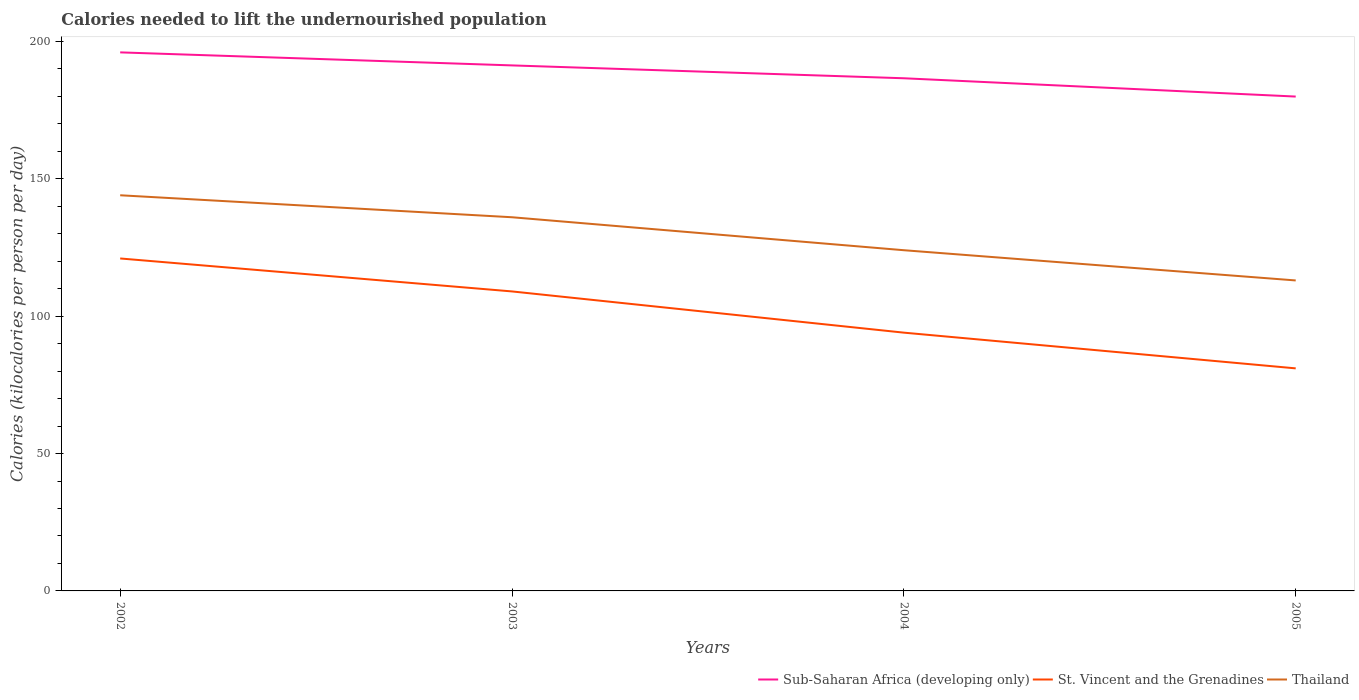How many different coloured lines are there?
Your answer should be very brief. 3. Does the line corresponding to Sub-Saharan Africa (developing only) intersect with the line corresponding to St. Vincent and the Grenadines?
Keep it short and to the point. No. Is the number of lines equal to the number of legend labels?
Provide a succinct answer. Yes. Across all years, what is the maximum total calories needed to lift the undernourished population in Sub-Saharan Africa (developing only)?
Make the answer very short. 179.92. In which year was the total calories needed to lift the undernourished population in Thailand maximum?
Ensure brevity in your answer.  2005. What is the total total calories needed to lift the undernourished population in Thailand in the graph?
Provide a short and direct response. 12. What is the difference between the highest and the second highest total calories needed to lift the undernourished population in St. Vincent and the Grenadines?
Keep it short and to the point. 40. How many years are there in the graph?
Keep it short and to the point. 4. Does the graph contain any zero values?
Give a very brief answer. No. How are the legend labels stacked?
Ensure brevity in your answer.  Horizontal. What is the title of the graph?
Make the answer very short. Calories needed to lift the undernourished population. What is the label or title of the Y-axis?
Your answer should be compact. Calories (kilocalories per person per day). What is the Calories (kilocalories per person per day) in Sub-Saharan Africa (developing only) in 2002?
Give a very brief answer. 196.01. What is the Calories (kilocalories per person per day) in St. Vincent and the Grenadines in 2002?
Your answer should be very brief. 121. What is the Calories (kilocalories per person per day) of Thailand in 2002?
Your answer should be compact. 144. What is the Calories (kilocalories per person per day) in Sub-Saharan Africa (developing only) in 2003?
Your answer should be very brief. 191.26. What is the Calories (kilocalories per person per day) of St. Vincent and the Grenadines in 2003?
Keep it short and to the point. 109. What is the Calories (kilocalories per person per day) in Thailand in 2003?
Offer a terse response. 136. What is the Calories (kilocalories per person per day) of Sub-Saharan Africa (developing only) in 2004?
Offer a very short reply. 186.58. What is the Calories (kilocalories per person per day) of St. Vincent and the Grenadines in 2004?
Ensure brevity in your answer.  94. What is the Calories (kilocalories per person per day) of Thailand in 2004?
Offer a terse response. 124. What is the Calories (kilocalories per person per day) in Sub-Saharan Africa (developing only) in 2005?
Your response must be concise. 179.92. What is the Calories (kilocalories per person per day) of St. Vincent and the Grenadines in 2005?
Provide a short and direct response. 81. What is the Calories (kilocalories per person per day) in Thailand in 2005?
Keep it short and to the point. 113. Across all years, what is the maximum Calories (kilocalories per person per day) in Sub-Saharan Africa (developing only)?
Provide a succinct answer. 196.01. Across all years, what is the maximum Calories (kilocalories per person per day) in St. Vincent and the Grenadines?
Keep it short and to the point. 121. Across all years, what is the maximum Calories (kilocalories per person per day) in Thailand?
Give a very brief answer. 144. Across all years, what is the minimum Calories (kilocalories per person per day) in Sub-Saharan Africa (developing only)?
Provide a short and direct response. 179.92. Across all years, what is the minimum Calories (kilocalories per person per day) of Thailand?
Your answer should be very brief. 113. What is the total Calories (kilocalories per person per day) of Sub-Saharan Africa (developing only) in the graph?
Keep it short and to the point. 753.78. What is the total Calories (kilocalories per person per day) of St. Vincent and the Grenadines in the graph?
Provide a succinct answer. 405. What is the total Calories (kilocalories per person per day) of Thailand in the graph?
Ensure brevity in your answer.  517. What is the difference between the Calories (kilocalories per person per day) of Sub-Saharan Africa (developing only) in 2002 and that in 2003?
Your answer should be compact. 4.74. What is the difference between the Calories (kilocalories per person per day) in St. Vincent and the Grenadines in 2002 and that in 2003?
Offer a terse response. 12. What is the difference between the Calories (kilocalories per person per day) in Sub-Saharan Africa (developing only) in 2002 and that in 2004?
Offer a very short reply. 9.42. What is the difference between the Calories (kilocalories per person per day) of Sub-Saharan Africa (developing only) in 2002 and that in 2005?
Provide a short and direct response. 16.08. What is the difference between the Calories (kilocalories per person per day) of St. Vincent and the Grenadines in 2002 and that in 2005?
Provide a succinct answer. 40. What is the difference between the Calories (kilocalories per person per day) of Sub-Saharan Africa (developing only) in 2003 and that in 2004?
Make the answer very short. 4.68. What is the difference between the Calories (kilocalories per person per day) of St. Vincent and the Grenadines in 2003 and that in 2004?
Keep it short and to the point. 15. What is the difference between the Calories (kilocalories per person per day) of Thailand in 2003 and that in 2004?
Give a very brief answer. 12. What is the difference between the Calories (kilocalories per person per day) in Sub-Saharan Africa (developing only) in 2003 and that in 2005?
Your response must be concise. 11.34. What is the difference between the Calories (kilocalories per person per day) of St. Vincent and the Grenadines in 2003 and that in 2005?
Offer a very short reply. 28. What is the difference between the Calories (kilocalories per person per day) of Sub-Saharan Africa (developing only) in 2004 and that in 2005?
Your answer should be compact. 6.66. What is the difference between the Calories (kilocalories per person per day) of Thailand in 2004 and that in 2005?
Your answer should be compact. 11. What is the difference between the Calories (kilocalories per person per day) of Sub-Saharan Africa (developing only) in 2002 and the Calories (kilocalories per person per day) of St. Vincent and the Grenadines in 2003?
Provide a succinct answer. 87.01. What is the difference between the Calories (kilocalories per person per day) of Sub-Saharan Africa (developing only) in 2002 and the Calories (kilocalories per person per day) of Thailand in 2003?
Keep it short and to the point. 60.01. What is the difference between the Calories (kilocalories per person per day) of St. Vincent and the Grenadines in 2002 and the Calories (kilocalories per person per day) of Thailand in 2003?
Offer a terse response. -15. What is the difference between the Calories (kilocalories per person per day) of Sub-Saharan Africa (developing only) in 2002 and the Calories (kilocalories per person per day) of St. Vincent and the Grenadines in 2004?
Your answer should be very brief. 102.01. What is the difference between the Calories (kilocalories per person per day) in Sub-Saharan Africa (developing only) in 2002 and the Calories (kilocalories per person per day) in Thailand in 2004?
Offer a very short reply. 72.01. What is the difference between the Calories (kilocalories per person per day) in St. Vincent and the Grenadines in 2002 and the Calories (kilocalories per person per day) in Thailand in 2004?
Provide a succinct answer. -3. What is the difference between the Calories (kilocalories per person per day) of Sub-Saharan Africa (developing only) in 2002 and the Calories (kilocalories per person per day) of St. Vincent and the Grenadines in 2005?
Make the answer very short. 115.01. What is the difference between the Calories (kilocalories per person per day) of Sub-Saharan Africa (developing only) in 2002 and the Calories (kilocalories per person per day) of Thailand in 2005?
Your answer should be very brief. 83.01. What is the difference between the Calories (kilocalories per person per day) in St. Vincent and the Grenadines in 2002 and the Calories (kilocalories per person per day) in Thailand in 2005?
Make the answer very short. 8. What is the difference between the Calories (kilocalories per person per day) in Sub-Saharan Africa (developing only) in 2003 and the Calories (kilocalories per person per day) in St. Vincent and the Grenadines in 2004?
Give a very brief answer. 97.26. What is the difference between the Calories (kilocalories per person per day) in Sub-Saharan Africa (developing only) in 2003 and the Calories (kilocalories per person per day) in Thailand in 2004?
Your response must be concise. 67.26. What is the difference between the Calories (kilocalories per person per day) in Sub-Saharan Africa (developing only) in 2003 and the Calories (kilocalories per person per day) in St. Vincent and the Grenadines in 2005?
Ensure brevity in your answer.  110.26. What is the difference between the Calories (kilocalories per person per day) in Sub-Saharan Africa (developing only) in 2003 and the Calories (kilocalories per person per day) in Thailand in 2005?
Your answer should be compact. 78.26. What is the difference between the Calories (kilocalories per person per day) of Sub-Saharan Africa (developing only) in 2004 and the Calories (kilocalories per person per day) of St. Vincent and the Grenadines in 2005?
Offer a very short reply. 105.58. What is the difference between the Calories (kilocalories per person per day) of Sub-Saharan Africa (developing only) in 2004 and the Calories (kilocalories per person per day) of Thailand in 2005?
Keep it short and to the point. 73.58. What is the difference between the Calories (kilocalories per person per day) in St. Vincent and the Grenadines in 2004 and the Calories (kilocalories per person per day) in Thailand in 2005?
Give a very brief answer. -19. What is the average Calories (kilocalories per person per day) of Sub-Saharan Africa (developing only) per year?
Give a very brief answer. 188.44. What is the average Calories (kilocalories per person per day) of St. Vincent and the Grenadines per year?
Provide a short and direct response. 101.25. What is the average Calories (kilocalories per person per day) in Thailand per year?
Your response must be concise. 129.25. In the year 2002, what is the difference between the Calories (kilocalories per person per day) of Sub-Saharan Africa (developing only) and Calories (kilocalories per person per day) of St. Vincent and the Grenadines?
Make the answer very short. 75.01. In the year 2002, what is the difference between the Calories (kilocalories per person per day) of Sub-Saharan Africa (developing only) and Calories (kilocalories per person per day) of Thailand?
Keep it short and to the point. 52.01. In the year 2003, what is the difference between the Calories (kilocalories per person per day) in Sub-Saharan Africa (developing only) and Calories (kilocalories per person per day) in St. Vincent and the Grenadines?
Ensure brevity in your answer.  82.26. In the year 2003, what is the difference between the Calories (kilocalories per person per day) of Sub-Saharan Africa (developing only) and Calories (kilocalories per person per day) of Thailand?
Offer a terse response. 55.26. In the year 2003, what is the difference between the Calories (kilocalories per person per day) in St. Vincent and the Grenadines and Calories (kilocalories per person per day) in Thailand?
Your answer should be very brief. -27. In the year 2004, what is the difference between the Calories (kilocalories per person per day) of Sub-Saharan Africa (developing only) and Calories (kilocalories per person per day) of St. Vincent and the Grenadines?
Provide a short and direct response. 92.58. In the year 2004, what is the difference between the Calories (kilocalories per person per day) of Sub-Saharan Africa (developing only) and Calories (kilocalories per person per day) of Thailand?
Your response must be concise. 62.58. In the year 2004, what is the difference between the Calories (kilocalories per person per day) in St. Vincent and the Grenadines and Calories (kilocalories per person per day) in Thailand?
Give a very brief answer. -30. In the year 2005, what is the difference between the Calories (kilocalories per person per day) of Sub-Saharan Africa (developing only) and Calories (kilocalories per person per day) of St. Vincent and the Grenadines?
Provide a short and direct response. 98.92. In the year 2005, what is the difference between the Calories (kilocalories per person per day) in Sub-Saharan Africa (developing only) and Calories (kilocalories per person per day) in Thailand?
Provide a succinct answer. 66.92. In the year 2005, what is the difference between the Calories (kilocalories per person per day) of St. Vincent and the Grenadines and Calories (kilocalories per person per day) of Thailand?
Your response must be concise. -32. What is the ratio of the Calories (kilocalories per person per day) in Sub-Saharan Africa (developing only) in 2002 to that in 2003?
Your answer should be very brief. 1.02. What is the ratio of the Calories (kilocalories per person per day) of St. Vincent and the Grenadines in 2002 to that in 2003?
Offer a terse response. 1.11. What is the ratio of the Calories (kilocalories per person per day) in Thailand in 2002 to that in 2003?
Keep it short and to the point. 1.06. What is the ratio of the Calories (kilocalories per person per day) in Sub-Saharan Africa (developing only) in 2002 to that in 2004?
Your response must be concise. 1.05. What is the ratio of the Calories (kilocalories per person per day) of St. Vincent and the Grenadines in 2002 to that in 2004?
Your answer should be compact. 1.29. What is the ratio of the Calories (kilocalories per person per day) of Thailand in 2002 to that in 2004?
Ensure brevity in your answer.  1.16. What is the ratio of the Calories (kilocalories per person per day) of Sub-Saharan Africa (developing only) in 2002 to that in 2005?
Ensure brevity in your answer.  1.09. What is the ratio of the Calories (kilocalories per person per day) in St. Vincent and the Grenadines in 2002 to that in 2005?
Ensure brevity in your answer.  1.49. What is the ratio of the Calories (kilocalories per person per day) of Thailand in 2002 to that in 2005?
Your answer should be compact. 1.27. What is the ratio of the Calories (kilocalories per person per day) in Sub-Saharan Africa (developing only) in 2003 to that in 2004?
Provide a short and direct response. 1.03. What is the ratio of the Calories (kilocalories per person per day) of St. Vincent and the Grenadines in 2003 to that in 2004?
Make the answer very short. 1.16. What is the ratio of the Calories (kilocalories per person per day) in Thailand in 2003 to that in 2004?
Provide a short and direct response. 1.1. What is the ratio of the Calories (kilocalories per person per day) in Sub-Saharan Africa (developing only) in 2003 to that in 2005?
Keep it short and to the point. 1.06. What is the ratio of the Calories (kilocalories per person per day) of St. Vincent and the Grenadines in 2003 to that in 2005?
Offer a terse response. 1.35. What is the ratio of the Calories (kilocalories per person per day) of Thailand in 2003 to that in 2005?
Your answer should be compact. 1.2. What is the ratio of the Calories (kilocalories per person per day) of St. Vincent and the Grenadines in 2004 to that in 2005?
Make the answer very short. 1.16. What is the ratio of the Calories (kilocalories per person per day) of Thailand in 2004 to that in 2005?
Offer a very short reply. 1.1. What is the difference between the highest and the second highest Calories (kilocalories per person per day) of Sub-Saharan Africa (developing only)?
Your response must be concise. 4.74. What is the difference between the highest and the lowest Calories (kilocalories per person per day) of Sub-Saharan Africa (developing only)?
Provide a succinct answer. 16.08. What is the difference between the highest and the lowest Calories (kilocalories per person per day) in Thailand?
Your answer should be very brief. 31. 